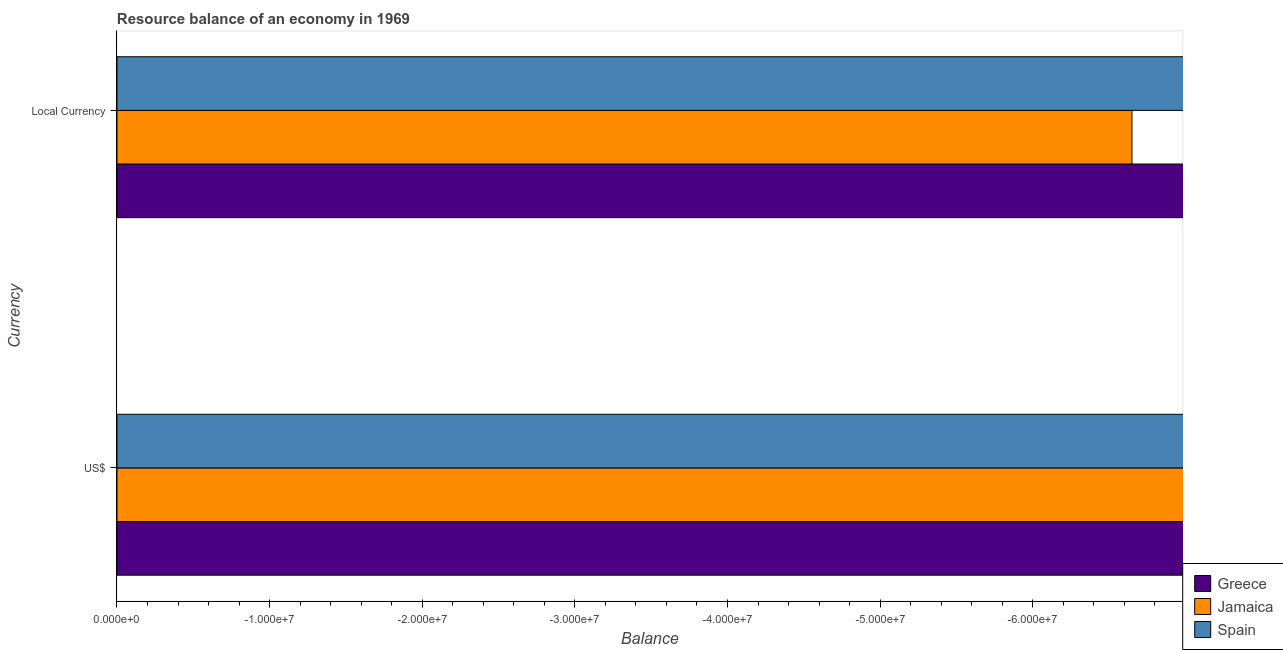Are the number of bars per tick equal to the number of legend labels?
Provide a short and direct response. No. Are the number of bars on each tick of the Y-axis equal?
Provide a short and direct response. Yes. How many bars are there on the 2nd tick from the bottom?
Provide a short and direct response. 0. What is the label of the 1st group of bars from the top?
Your response must be concise. Local Currency. What is the resource balance in us$ in Greece?
Provide a short and direct response. 0. What is the difference between the resource balance in us$ in Spain and the resource balance in constant us$ in Greece?
Make the answer very short. 0. In how many countries, is the resource balance in constant us$ greater than -10000000 units?
Ensure brevity in your answer.  0. In how many countries, is the resource balance in us$ greater than the average resource balance in us$ taken over all countries?
Make the answer very short. 0. Are all the bars in the graph horizontal?
Ensure brevity in your answer.  Yes. What is the difference between two consecutive major ticks on the X-axis?
Offer a very short reply. 1.00e+07. Does the graph contain any zero values?
Keep it short and to the point. Yes. Does the graph contain grids?
Offer a terse response. No. Where does the legend appear in the graph?
Give a very brief answer. Bottom right. How many legend labels are there?
Keep it short and to the point. 3. What is the title of the graph?
Your answer should be compact. Resource balance of an economy in 1969. What is the label or title of the X-axis?
Your answer should be very brief. Balance. What is the label or title of the Y-axis?
Keep it short and to the point. Currency. What is the Balance of Greece in Local Currency?
Your response must be concise. 0. What is the Balance of Spain in Local Currency?
Your answer should be very brief. 0. What is the total Balance in Greece in the graph?
Provide a short and direct response. 0. What is the total Balance of Spain in the graph?
Your answer should be very brief. 0. What is the average Balance of Greece per Currency?
Provide a succinct answer. 0. What is the average Balance in Jamaica per Currency?
Your answer should be compact. 0. What is the average Balance in Spain per Currency?
Keep it short and to the point. 0. 